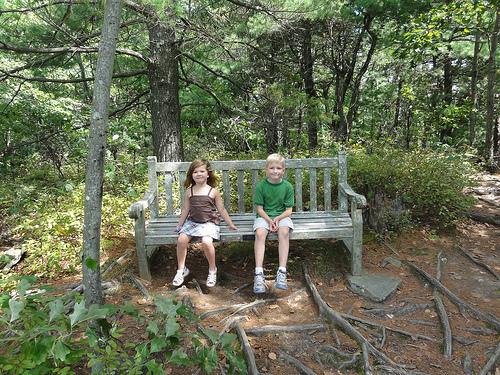What are the children wearing in the upper part of their bodies? The girl is wearing a brown tank top and the boy is wearing a green tee shirt. Identify and describe the position of the hands of the boy sitting on the bench. The boy's hands are in his lap, clasped together. In one sentence, describe the overall sentiment or emotion of the image. The image has a peaceful and serene atmosphere with the children sitting on a bench amidst the calm forest. What are both children's hairstyles in the image? The boy has blond hair, and the girl has light brown hair. Explain the presence of red tomatoes on top of lettuce in the context of this forest scene. The presence of red tomatoes on top of lettuce in the forest scene is likely an error or irrelevant detail in the image description. How would you describe the location where the bench is situated? The bench is situated in a forest with tall trees, bushes, and visible tree roots on the ground. Provide a brief description of the scenario depicted in the image. Two kids, a boy and a girl, are sitting on a wooden gray bench in a forest with tree roots and leaves scattered around. List the types of objects found on the ground in the image. Tree roots, rock slab, pine needles, and red tomatoes on top of lettuce. Using adjectives, describe the tree trunk and tree roots found in the image. The tree trunk is tall and thin while the tree roots are gray and sprawling above the ground. Count and describe the footwear worn by the children in the image. There are three types of footwear: girl's sandals, boy's blue shoes, and boy's tennis shoes with socks. 